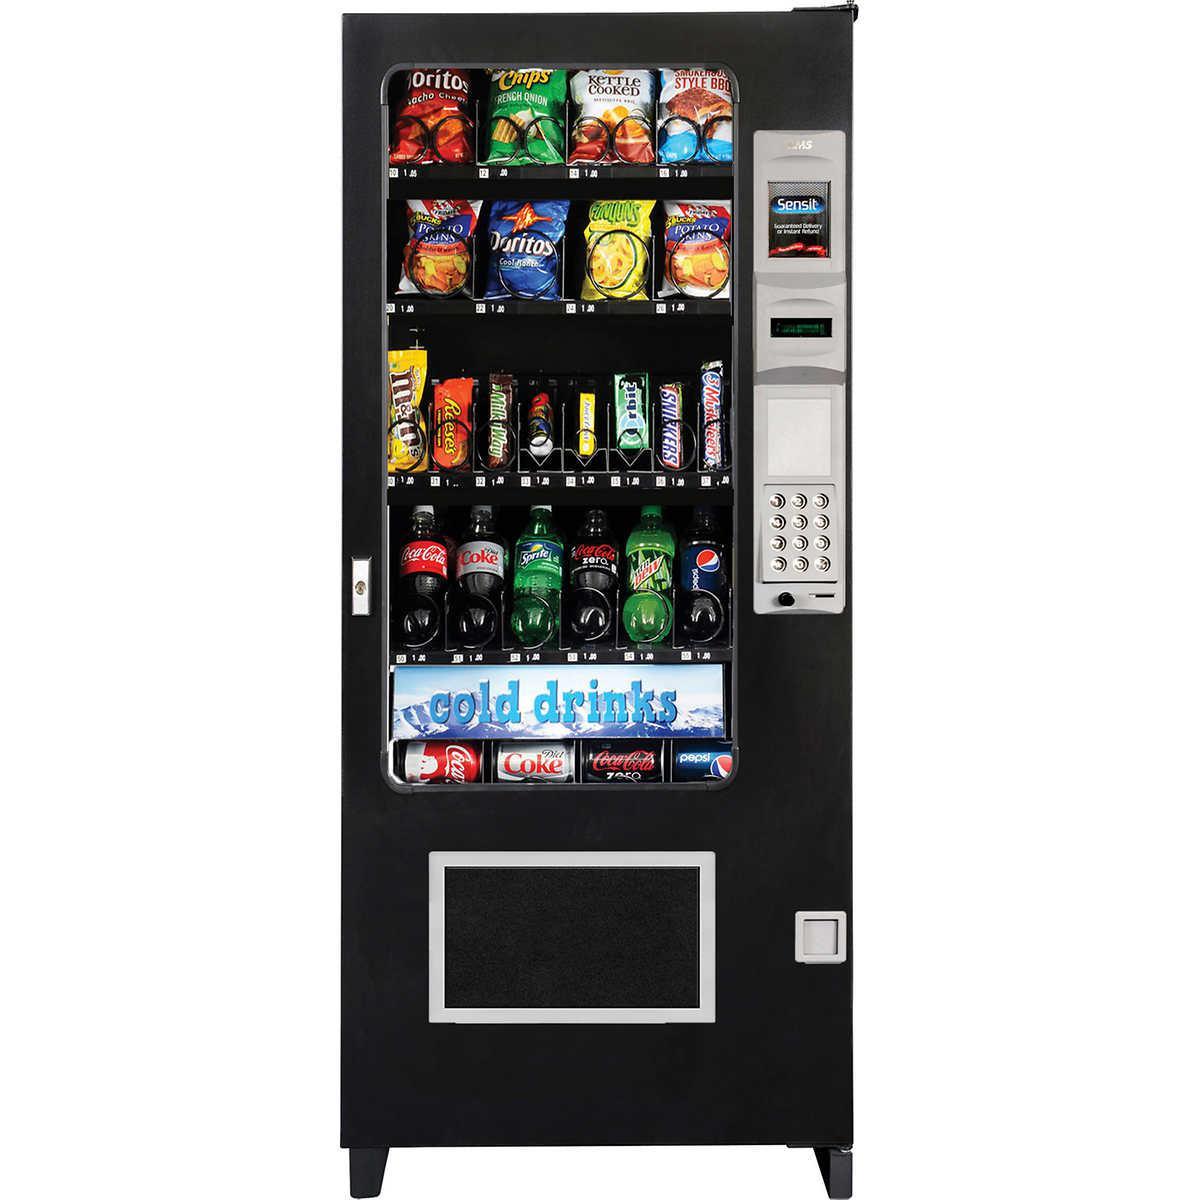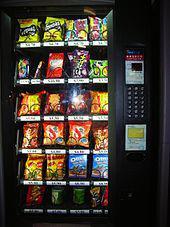The first image is the image on the left, the second image is the image on the right. Evaluate the accuracy of this statement regarding the images: "The dispensing port of the vending machine in the image on the left is outlined by a gray rectangle.". Is it true? Answer yes or no. Yes. 